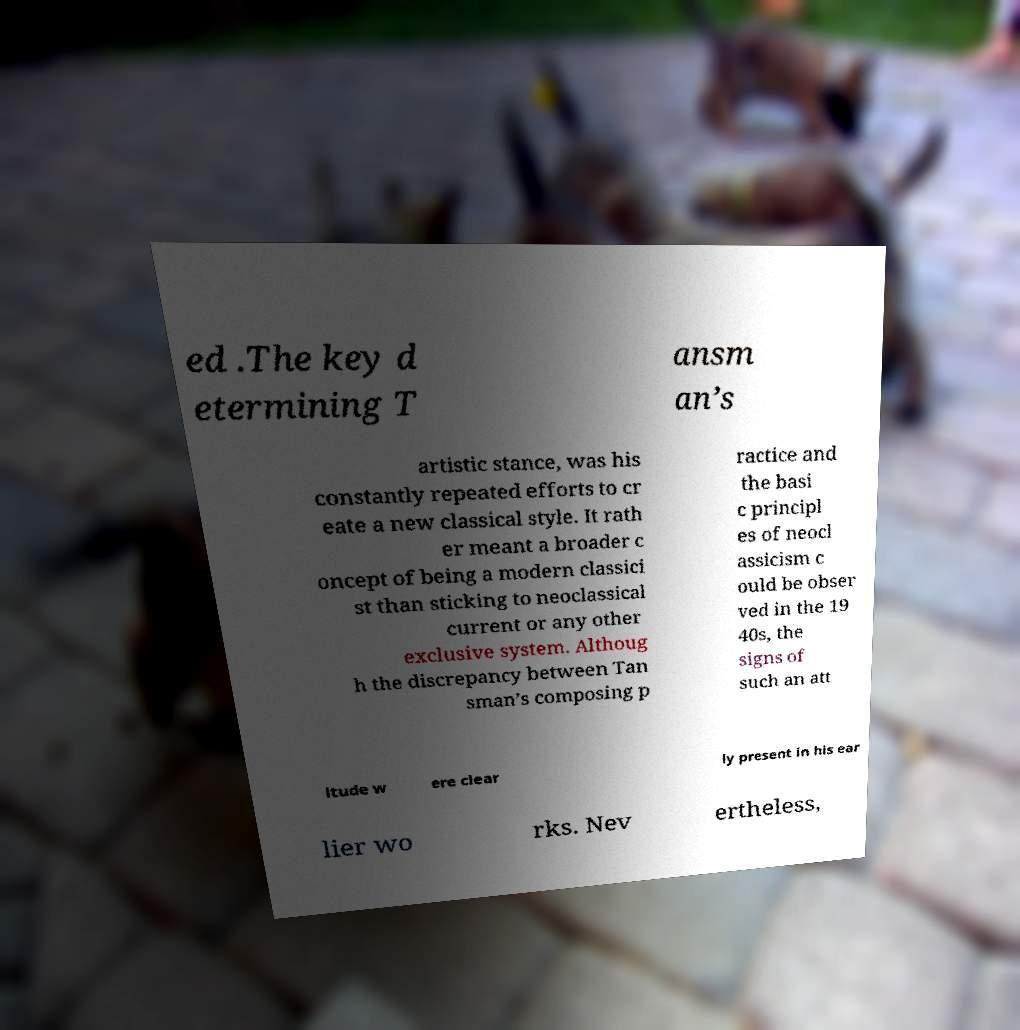Please identify and transcribe the text found in this image. ed .The key d etermining T ansm an’s artistic stance, was his constantly repeated efforts to cr eate a new classical style. It rath er meant a broader c oncept of being a modern classici st than sticking to neoclassical current or any other exclusive system. Althoug h the discrepancy between Tan sman’s composing p ractice and the basi c principl es of neocl assicism c ould be obser ved in the 19 40s, the signs of such an att itude w ere clear ly present in his ear lier wo rks. Nev ertheless, 